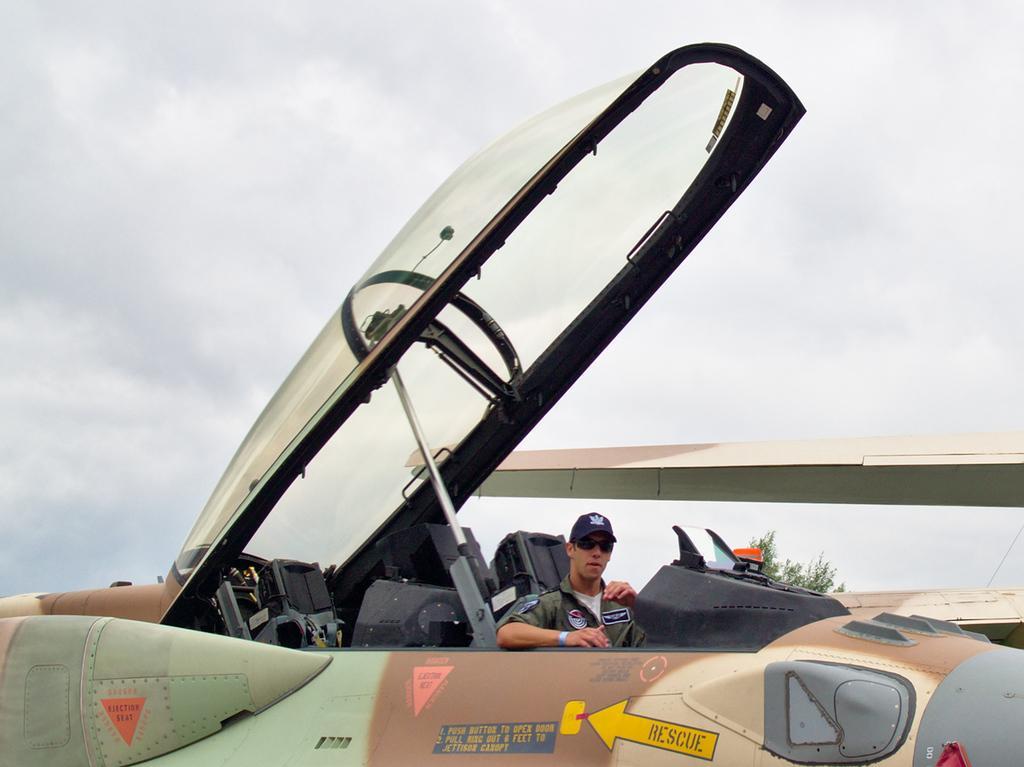How would you summarize this image in a sentence or two? In this picture we can see airplanes, tree and a man wore a cap and goggles and in the background we can see the sky with clouds. 